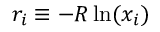Convert formula to latex. <formula><loc_0><loc_0><loc_500><loc_500>r _ { i } \equiv - R \ln ( x _ { i } )</formula> 